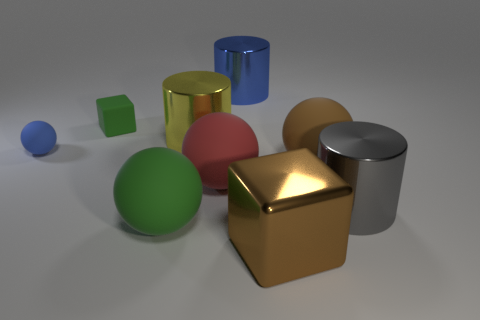Can you tell me what the textures of the objects in the image are? Certainly! In the image, the various objects present different textures. The blue and green spheres as well as the yellow cube have a matte finish. The red sphere, the golden cube, and the silver cylinder exhibit shiny, reflective surfaces, indicating that they are likely metallic or have a polished texture. 